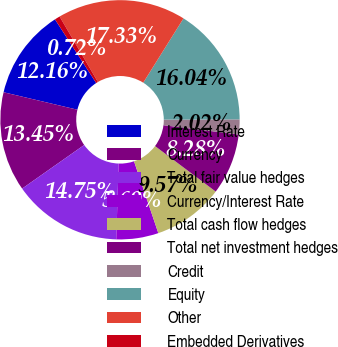Convert chart. <chart><loc_0><loc_0><loc_500><loc_500><pie_chart><fcel>Interest Rate<fcel>Currency<fcel>Total fair value hedges<fcel>Currency/Interest Rate<fcel>Total cash flow hedges<fcel>Total net investment hedges<fcel>Credit<fcel>Equity<fcel>Other<fcel>Embedded Derivatives<nl><fcel>12.16%<fcel>13.45%<fcel>14.75%<fcel>5.69%<fcel>9.57%<fcel>8.28%<fcel>2.02%<fcel>16.04%<fcel>17.33%<fcel>0.72%<nl></chart> 